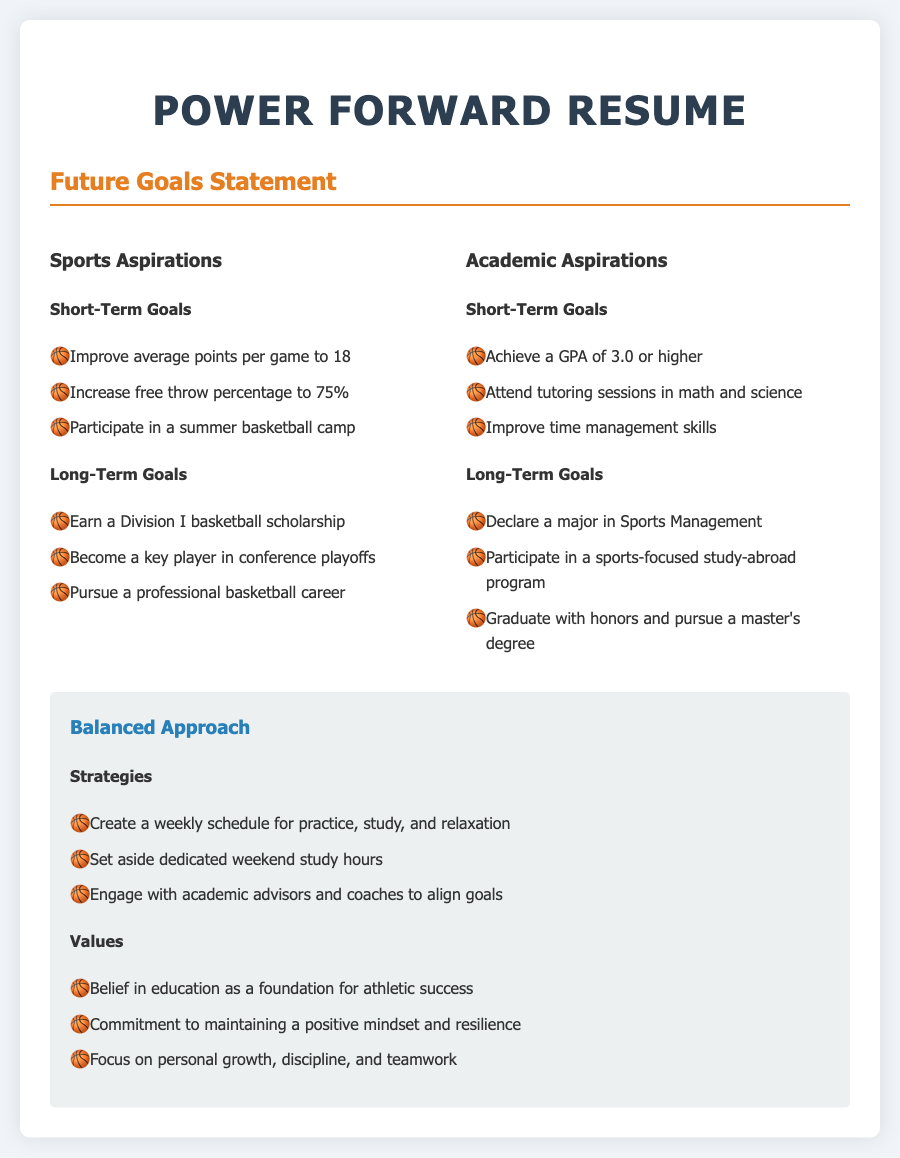What are the short-term sports goals? The short-term sports goals listed are improving average points per game to 18, increasing free throw percentage to 75%, and participating in a summer basketball camp.
Answer: Improve average points per game to 18, increase free throw percentage to 75%, participate in a summer basketball camp What is the desired GPA in the academic aspirations? The desired GPA in the academic aspirations is specified as 3.0 or higher.
Answer: 3.0 or higher What is one long-term academic goal? One long-term academic goal listed is to declare a major in Sports Management.
Answer: Declare a major in Sports Management How many strategies are listed under the balanced approach? There are three strategies listed under the balanced approach.
Answer: three Which sport does the individual want to play professionally? The individual aspires to pursue a professional basketball career.
Answer: basketball What is a value emphasized in the balanced approach? One of the values emphasized is the belief in education as a foundation for athletic success.
Answer: belief in education as a foundation for athletic success What is the ultimate aim for college after high school? The ultimate aim for college after high school is to earn a Division I basketball scholarship.
Answer: earn a Division I basketball scholarship What is a specific method mentioned for improving academic performance? One specific method mentioned for improving academic performance is attending tutoring sessions in math and science.
Answer: attending tutoring sessions in math and science 